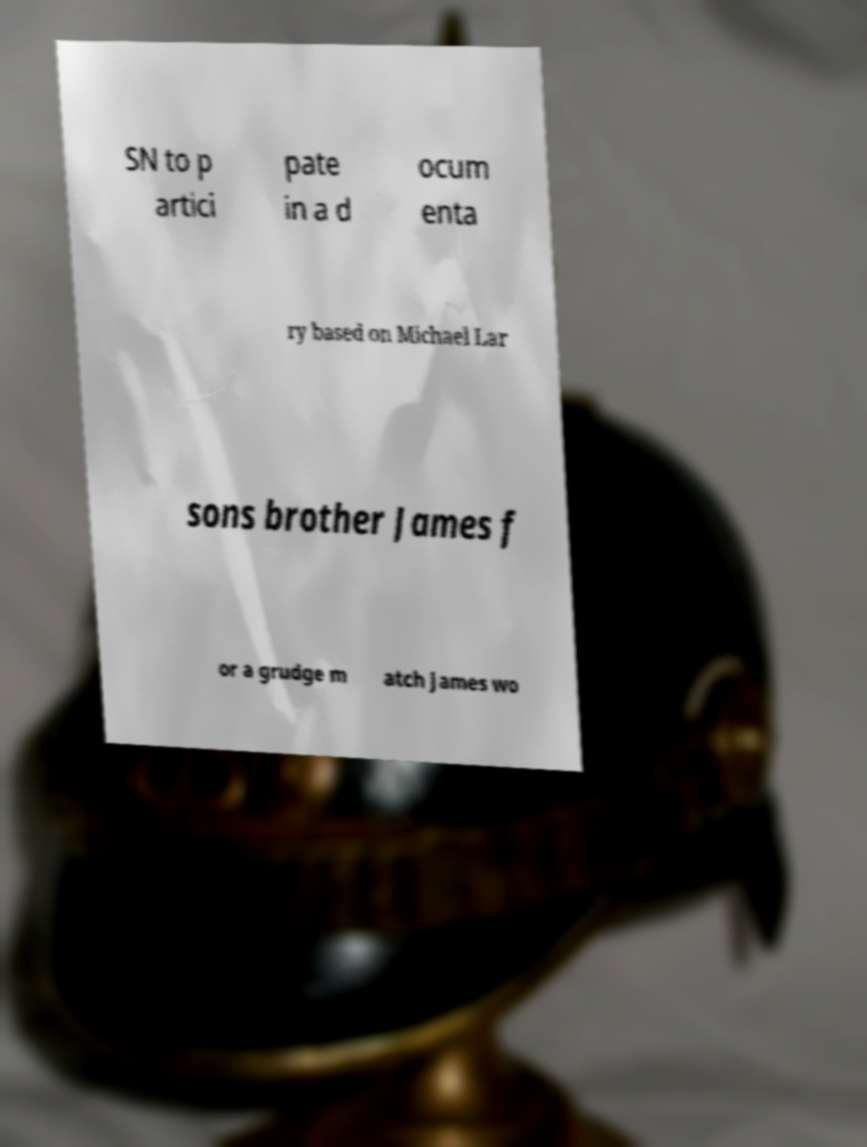For documentation purposes, I need the text within this image transcribed. Could you provide that? SN to p artici pate in a d ocum enta ry based on Michael Lar sons brother James f or a grudge m atch James wo 